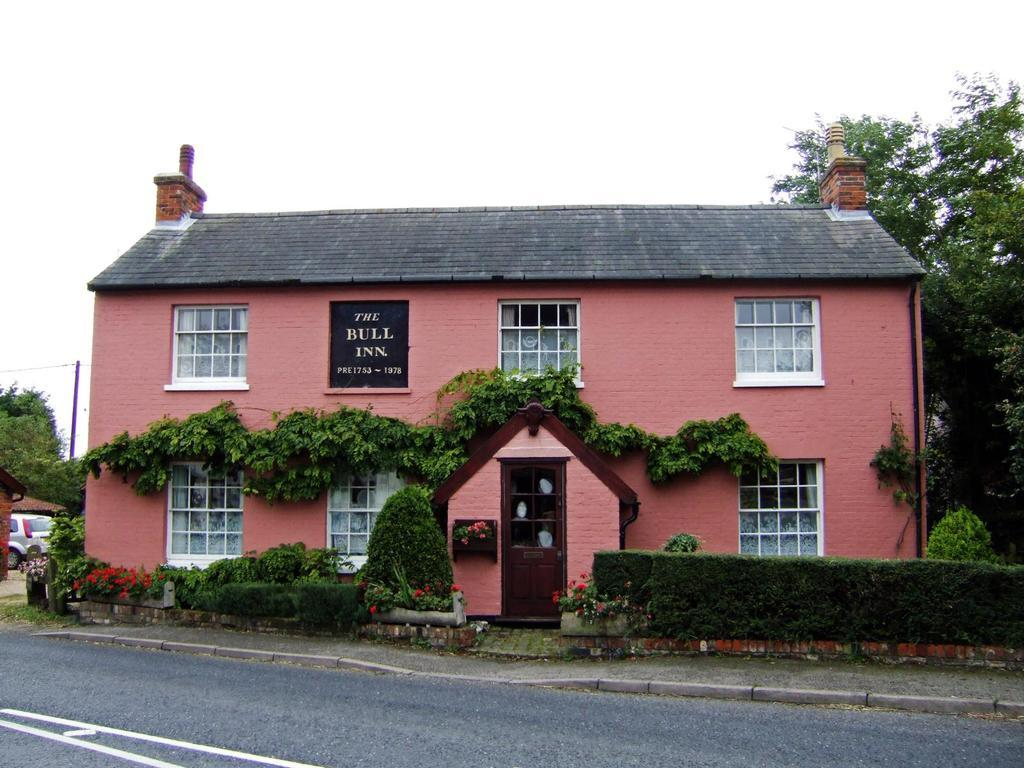What type of structure is present in the image? There is a building in the image. What is the color of the building? The building is in peach color. What other elements can be seen in the image besides the building? There are plants in the image. What is the color of the plants? The plants are in green color. What can be seen in the background of the image? The sky is visible in the background of the image. What is the color of the sky? The sky is in blue color. What type of wood is used to construct the chain in the image? There is no chain or wood present in the image. Who is the uncle in the image? There is no uncle present in the image. 